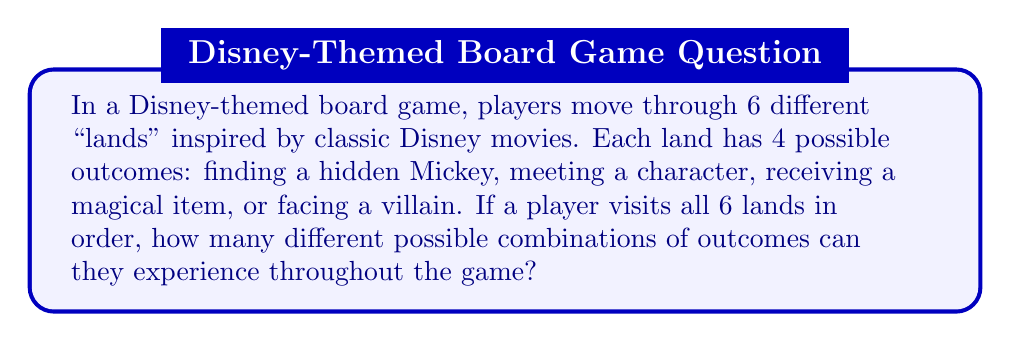Solve this math problem. Let's approach this step-by-step:

1) For each land, there are 4 possible outcomes.

2) The player must go through all 6 lands in order.

3) This scenario is a perfect example of the Multiplication Principle in combinatorics. When we have a sequence of independent events, and we want to know the total number of possible outcomes, we multiply the number of possibilities for each event.

4) In this case, we have:
   - 4 possibilities for the first land
   - 4 possibilities for the second land
   - 4 possibilities for the third land
   - 4 possibilities for the fourth land
   - 4 possibilities for the fifth land
   - 4 possibilities for the sixth land

5) Therefore, the total number of possible combinations is:

   $$ 4 \times 4 \times 4 \times 4 \times 4 \times 4 = 4^6 $$

6) We can calculate this:
   $$ 4^6 = 4 \times 4 \times 4 \times 4 \times 4 \times 4 = 4,096 $$

Thus, there are 4,096 different possible combinations of outcomes a player can experience throughout the game.
Answer: $4^6 = 4,096$ 